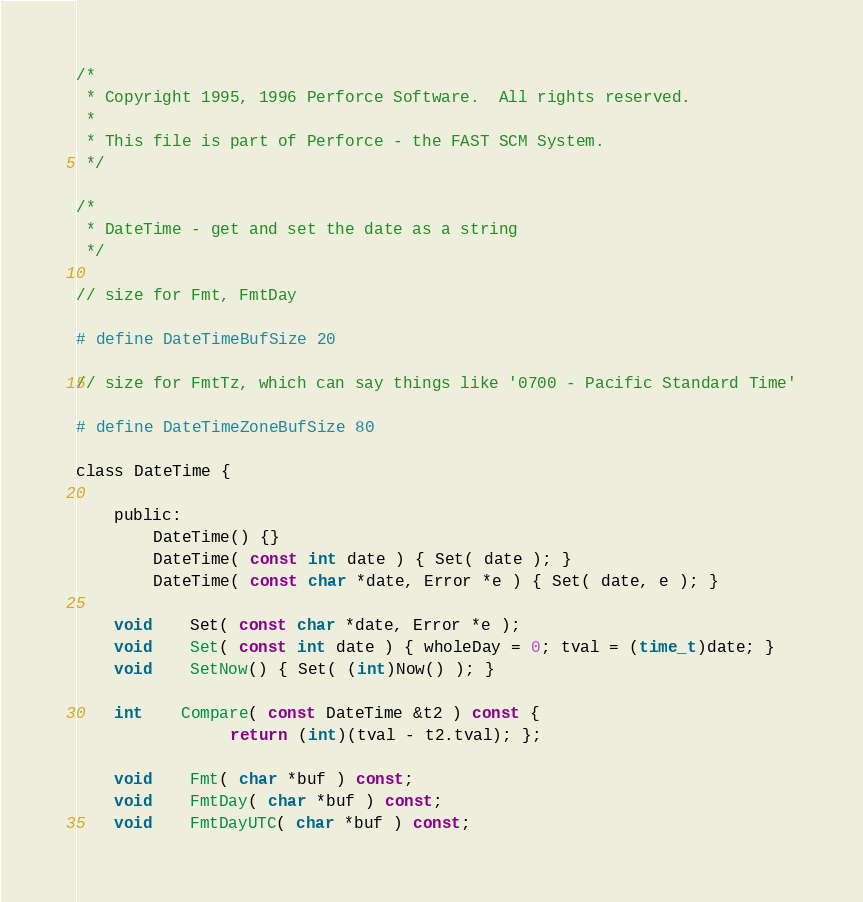Convert code to text. <code><loc_0><loc_0><loc_500><loc_500><_C_>/*
 * Copyright 1995, 1996 Perforce Software.  All rights reserved.
 *
 * This file is part of Perforce - the FAST SCM System.
 */

/*
 * DateTime - get and set the date as a string
 */

// size for Fmt, FmtDay

# define DateTimeBufSize 20 

// size for FmtTz, which can say things like '0700 - Pacific Standard Time'

# define DateTimeZoneBufSize 80 

class DateTime {

    public:
		DateTime() {}
		DateTime( const int date ) { Set( date ); }
		DateTime( const char *date, Error *e ) { Set( date, e ); }

 	void	Set( const char *date, Error *e );
 	void	Set( const int date ) { wholeDay = 0; tval = (time_t)date; }
	void	SetNow() { Set( (int)Now() ); }

	int 	Compare( const DateTime &t2 ) const { 
                return (int)(tval - t2.tval); };

	void	Fmt( char *buf ) const;
	void	FmtDay( char *buf ) const;
	void	FmtDayUTC( char *buf ) const;</code> 